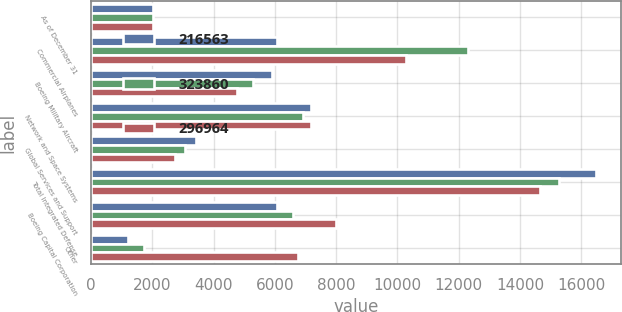Convert chart. <chart><loc_0><loc_0><loc_500><loc_500><stacked_bar_chart><ecel><fcel>As of December 31<fcel>Commercial Airplanes<fcel>Boeing Military Aircraft<fcel>Network and Space Systems<fcel>Global Services and Support<fcel>Total Integrated Defense<fcel>Boeing Capital Corporation<fcel>Other<nl><fcel>216563<fcel>2008<fcel>6073<fcel>5897<fcel>7176<fcel>3409<fcel>16482<fcel>6073<fcel>1207<nl><fcel>323860<fcel>2007<fcel>12317<fcel>5283<fcel>6924<fcel>3063<fcel>15270<fcel>6581<fcel>1735<nl><fcel>296964<fcel>2006<fcel>10296<fcel>4760<fcel>7175<fcel>2731<fcel>14666<fcel>7987<fcel>6756<nl></chart> 